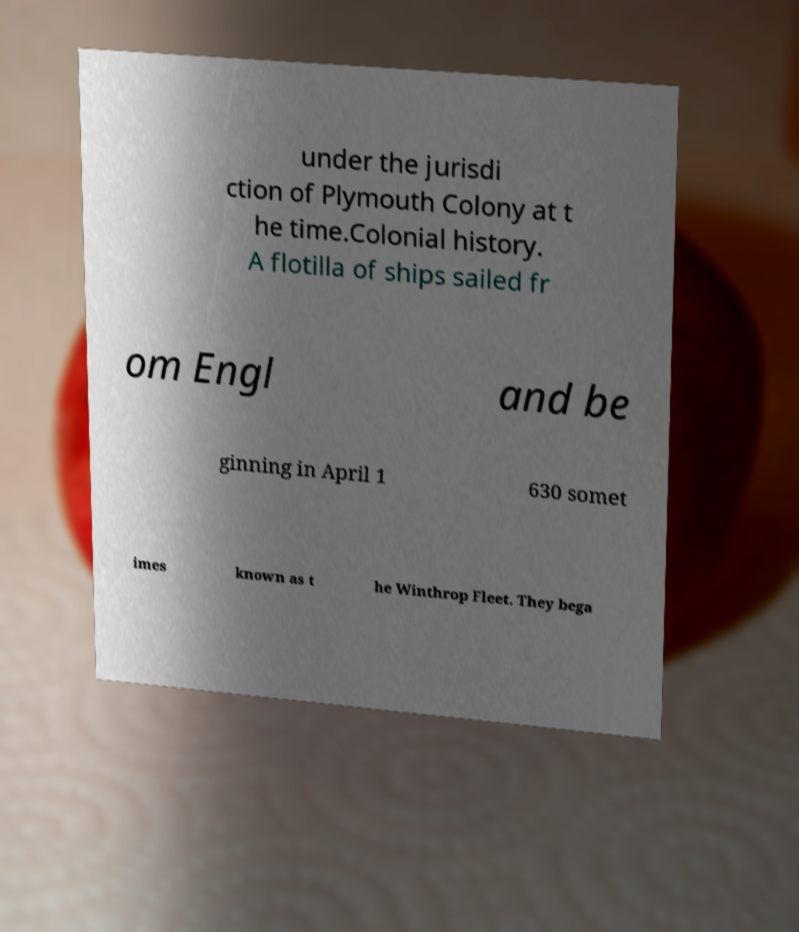I need the written content from this picture converted into text. Can you do that? under the jurisdi ction of Plymouth Colony at t he time.Colonial history. A flotilla of ships sailed fr om Engl and be ginning in April 1 630 somet imes known as t he Winthrop Fleet. They bega 